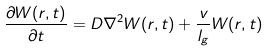Convert formula to latex. <formula><loc_0><loc_0><loc_500><loc_500>\frac { \partial W ( r , t ) } { \partial t } = D \nabla ^ { 2 } W ( r , t ) + \frac { v } { l _ { g } } W ( r , t )</formula> 